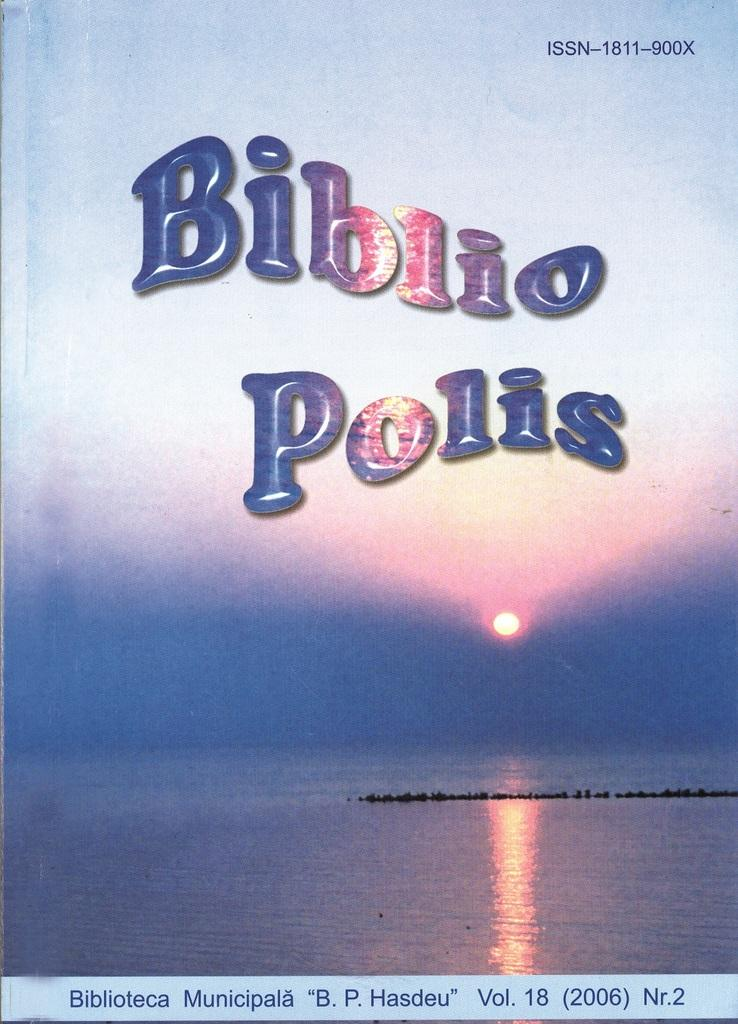<image>
Create a compact narrative representing the image presented. A book cover that says Biblio Polis and shows a sunset over a lake. 